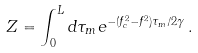<formula> <loc_0><loc_0><loc_500><loc_500>Z = \int _ { 0 } ^ { L } d \tau _ { m } e ^ { - ( f _ { c } ^ { 2 } - f ^ { 2 } ) \tau _ { m } / 2 \gamma } \, .</formula> 